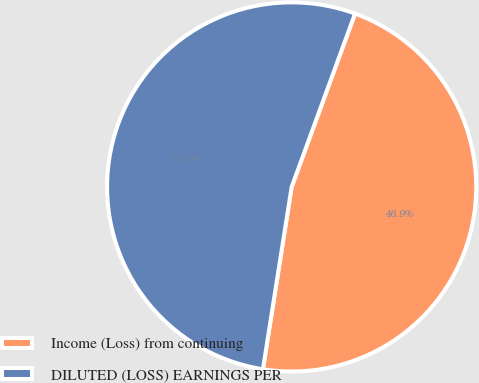Convert chart to OTSL. <chart><loc_0><loc_0><loc_500><loc_500><pie_chart><fcel>Income (Loss) from continuing<fcel>DILUTED (LOSS) EARNINGS PER<nl><fcel>46.91%<fcel>53.09%<nl></chart> 